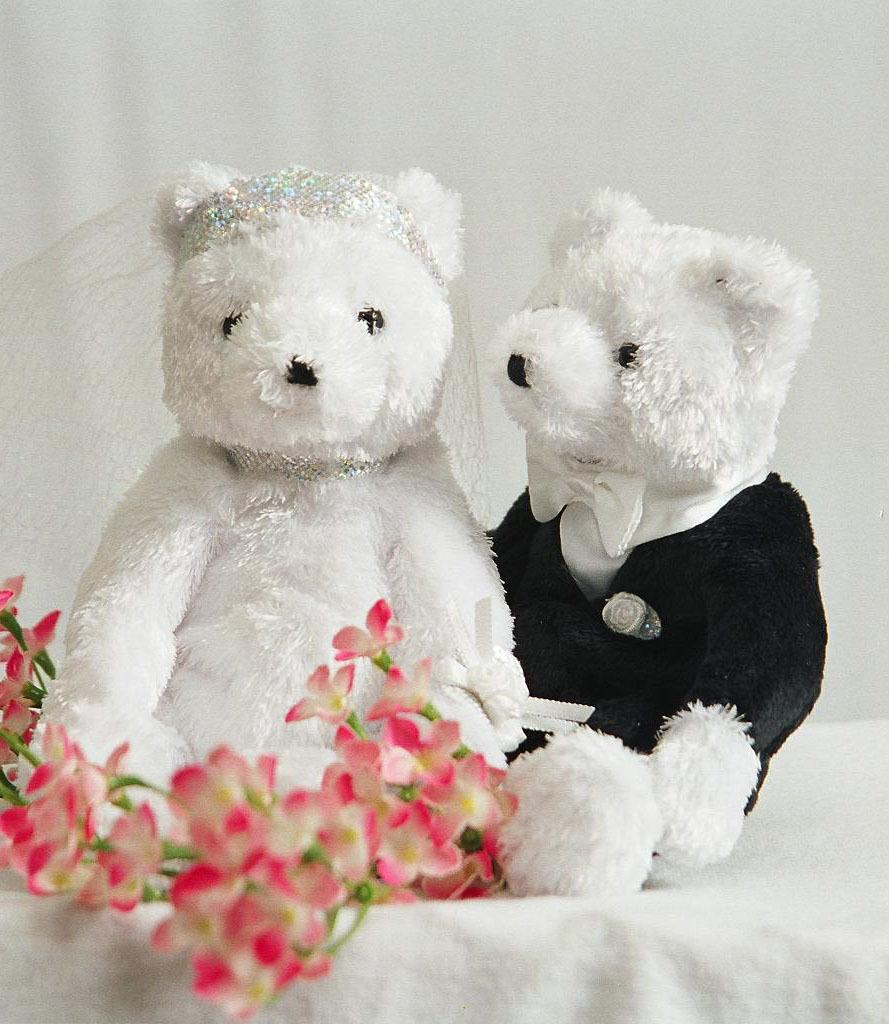How many dolls are in the image? There are two dolls in the image. What are the colors of the dolls? One doll is white, and the other is black. What other objects or elements can be seen in the image? There are flowers in the image. What color are the flowers? The flowers are red. How does the wax melt in the image? There is no wax present in the image, so it cannot melt. 